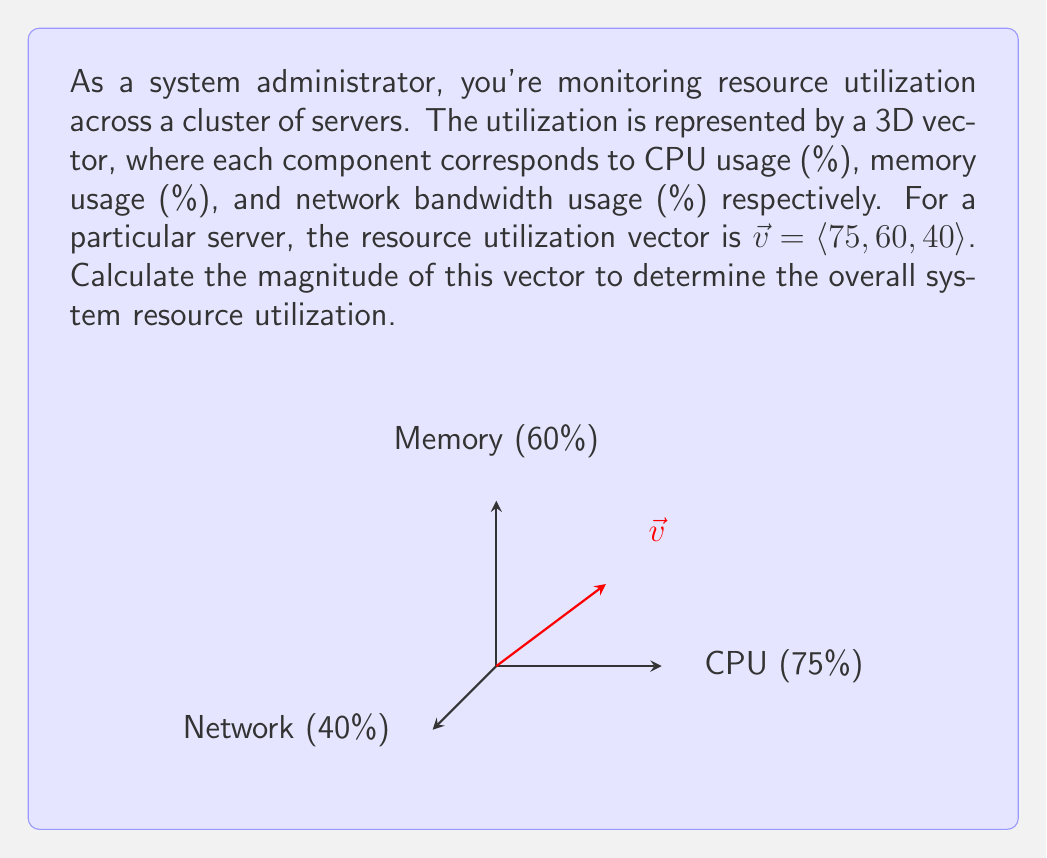Can you solve this math problem? To compute the magnitude of the vector $\vec{v} = \langle 75, 60, 40 \rangle$, we use the formula for the magnitude of a 3D vector:

$$\|\vec{v}\| = \sqrt{x^2 + y^2 + z^2}$$

Where $x$, $y$, and $z$ are the components of the vector.

Step 1: Substitute the values into the formula:
$$\|\vec{v}\| = \sqrt{75^2 + 60^2 + 40^2}$$

Step 2: Calculate the squares:
$$\|\vec{v}\| = \sqrt{5625 + 3600 + 1600}$$

Step 3: Sum the values under the square root:
$$\|\vec{v}\| = \sqrt{10825}$$

Step 4: Calculate the square root:
$$\|\vec{v}\| \approx 104.04$$

The magnitude represents the Euclidean distance from the origin to the point (75, 60, 40) in 3D space, which can be interpreted as an overall measure of system resource utilization.
Answer: $104.04$ 